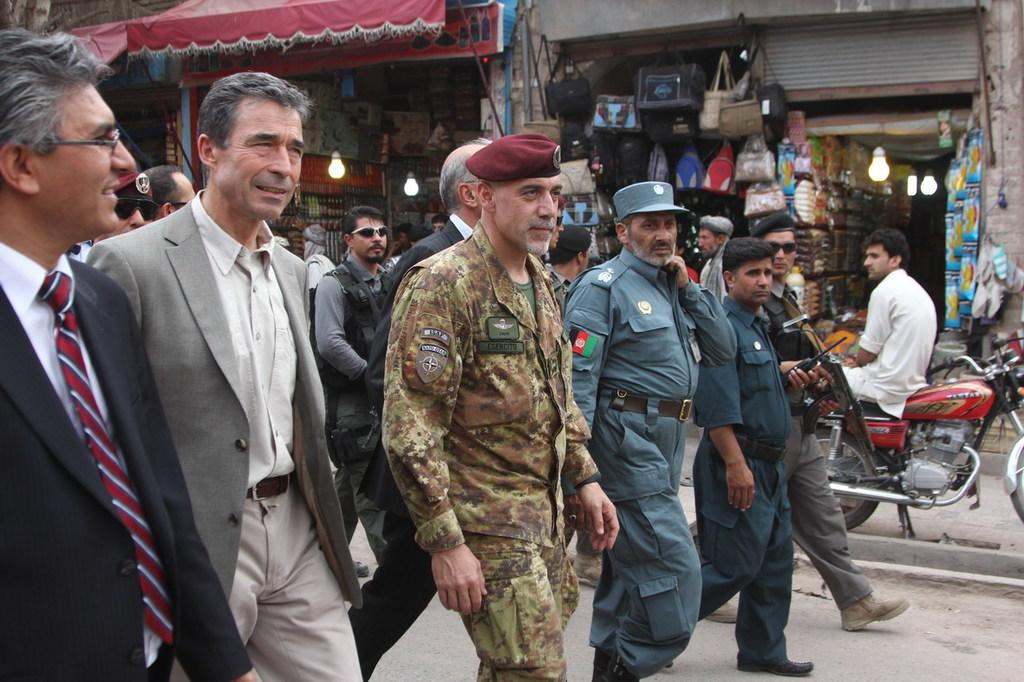What are the people in the image doing? There are persons walking on the road in the image. What can be seen in the background of the image? There are stalls in the background of the image. Can you describe the person seated on a bike? There is a person seated on a bike in the image. What type of note is the person on the bike holding in the image? There is no note visible in the image; the person on the bike is not holding anything. 